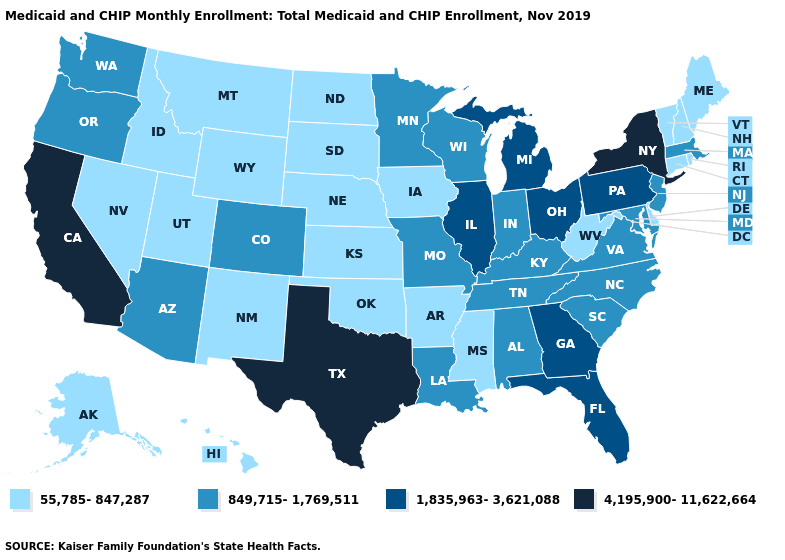How many symbols are there in the legend?
Be succinct. 4. Name the states that have a value in the range 849,715-1,769,511?
Quick response, please. Alabama, Arizona, Colorado, Indiana, Kentucky, Louisiana, Maryland, Massachusetts, Minnesota, Missouri, New Jersey, North Carolina, Oregon, South Carolina, Tennessee, Virginia, Washington, Wisconsin. Which states have the lowest value in the USA?
Give a very brief answer. Alaska, Arkansas, Connecticut, Delaware, Hawaii, Idaho, Iowa, Kansas, Maine, Mississippi, Montana, Nebraska, Nevada, New Hampshire, New Mexico, North Dakota, Oklahoma, Rhode Island, South Dakota, Utah, Vermont, West Virginia, Wyoming. Among the states that border Alabama , does Georgia have the highest value?
Answer briefly. Yes. Name the states that have a value in the range 4,195,900-11,622,664?
Answer briefly. California, New York, Texas. What is the highest value in the MidWest ?
Write a very short answer. 1,835,963-3,621,088. What is the lowest value in states that border North Carolina?
Answer briefly. 849,715-1,769,511. What is the value of Ohio?
Quick response, please. 1,835,963-3,621,088. Name the states that have a value in the range 55,785-847,287?
Answer briefly. Alaska, Arkansas, Connecticut, Delaware, Hawaii, Idaho, Iowa, Kansas, Maine, Mississippi, Montana, Nebraska, Nevada, New Hampshire, New Mexico, North Dakota, Oklahoma, Rhode Island, South Dakota, Utah, Vermont, West Virginia, Wyoming. Does New York have the highest value in the Northeast?
Be succinct. Yes. Does the map have missing data?
Give a very brief answer. No. Name the states that have a value in the range 4,195,900-11,622,664?
Give a very brief answer. California, New York, Texas. Among the states that border Oregon , does Nevada have the lowest value?
Keep it brief. Yes. What is the lowest value in the USA?
Quick response, please. 55,785-847,287. 